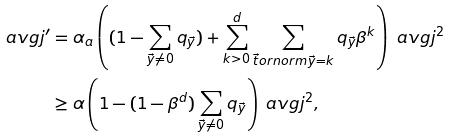Convert formula to latex. <formula><loc_0><loc_0><loc_500><loc_500>\ a v g j ^ { \prime } & = \alpha _ { a } \left ( ( 1 - \sum _ { \vec { y } \neq 0 } q _ { \vec { y } } ) + \sum _ { k > 0 } ^ { d } \sum _ { \vec { t } o r n o r m { \vec { y } } = k } q _ { \vec { y } } \beta ^ { k } \right ) \ a v g j ^ { 2 } \\ & \geq \alpha \left ( 1 - ( 1 - \beta ^ { d } ) \sum _ { \vec { y } \neq 0 } q _ { \vec { y } } \right ) \ a v g j ^ { 2 } ,</formula> 